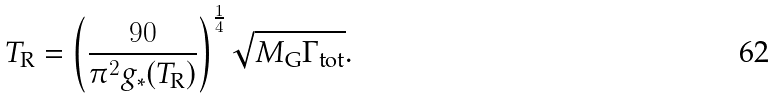Convert formula to latex. <formula><loc_0><loc_0><loc_500><loc_500>T _ { \text {R} } = \left ( \frac { 9 0 } { \pi ^ { 2 } g _ { * } ( T _ { \text {R} } ) } \right ) ^ { \frac { 1 } { 4 } } \sqrt { M _ { \text {G} } \Gamma _ { \text {tot} } } .</formula> 